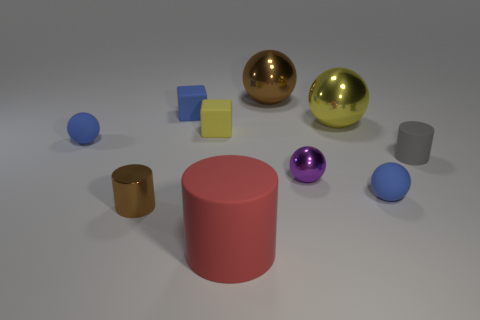How many tiny purple spheres have the same material as the purple thing?
Your response must be concise. 0. There is a rubber cylinder behind the brown cylinder; does it have the same size as the purple ball?
Ensure brevity in your answer.  Yes. What is the color of the other small cube that is the same material as the tiny blue block?
Your answer should be very brief. Yellow. Is there anything else that has the same size as the brown metallic cylinder?
Ensure brevity in your answer.  Yes. There is a yellow metallic object; how many large brown metal balls are in front of it?
Your response must be concise. 0. There is a tiny metal thing that is behind the tiny brown shiny object; does it have the same color as the sphere that is left of the large red thing?
Ensure brevity in your answer.  No. What color is the shiny thing that is the same shape as the tiny gray rubber object?
Keep it short and to the point. Brown. Are there any other things that have the same shape as the yellow rubber object?
Your answer should be compact. Yes. There is a blue thing in front of the small gray matte object; is its shape the same as the tiny metal object left of the purple metallic ball?
Ensure brevity in your answer.  No. Is the size of the red matte cylinder the same as the blue ball to the right of the yellow metal sphere?
Keep it short and to the point. No. 